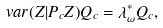Convert formula to latex. <formula><loc_0><loc_0><loc_500><loc_500>\ v a r ( Z | P _ { c } Z ) Q _ { c } = \lambda ^ { \ast } _ { \omega } Q _ { c } ,</formula> 